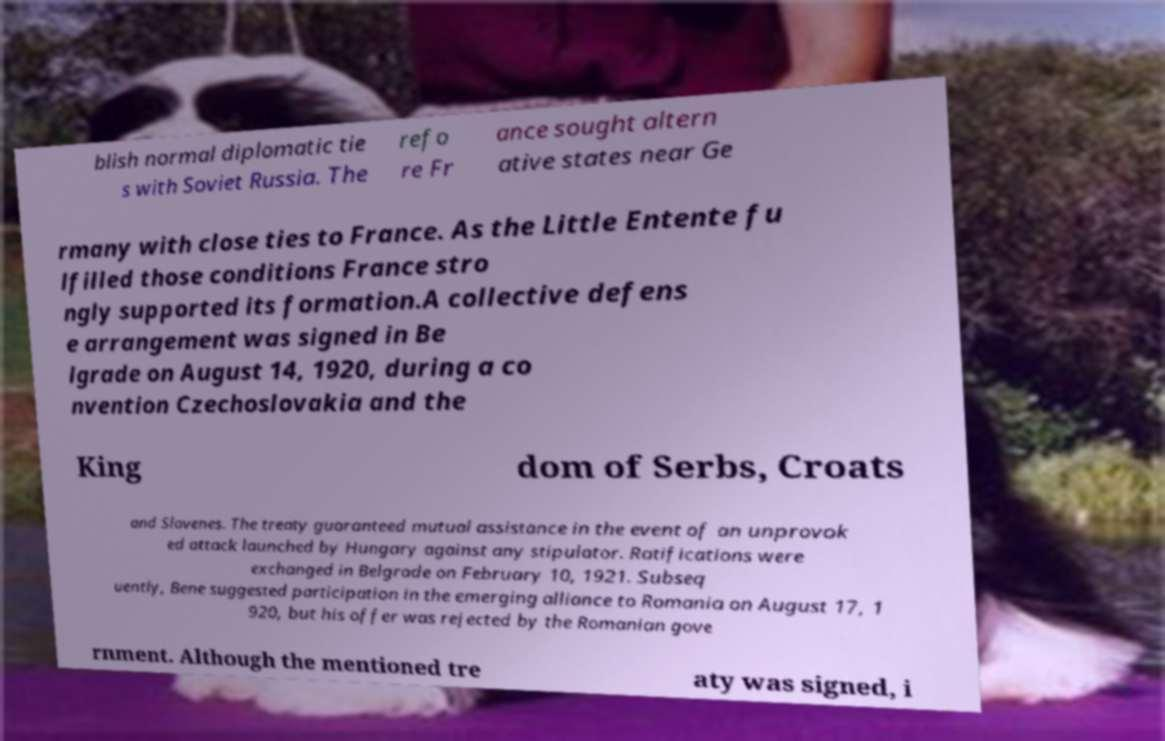Can you read and provide the text displayed in the image?This photo seems to have some interesting text. Can you extract and type it out for me? blish normal diplomatic tie s with Soviet Russia. The refo re Fr ance sought altern ative states near Ge rmany with close ties to France. As the Little Entente fu lfilled those conditions France stro ngly supported its formation.A collective defens e arrangement was signed in Be lgrade on August 14, 1920, during a co nvention Czechoslovakia and the King dom of Serbs, Croats and Slovenes. The treaty guaranteed mutual assistance in the event of an unprovok ed attack launched by Hungary against any stipulator. Ratifications were exchanged in Belgrade on February 10, 1921. Subseq uently, Bene suggested participation in the emerging alliance to Romania on August 17, 1 920, but his offer was rejected by the Romanian gove rnment. Although the mentioned tre aty was signed, i 